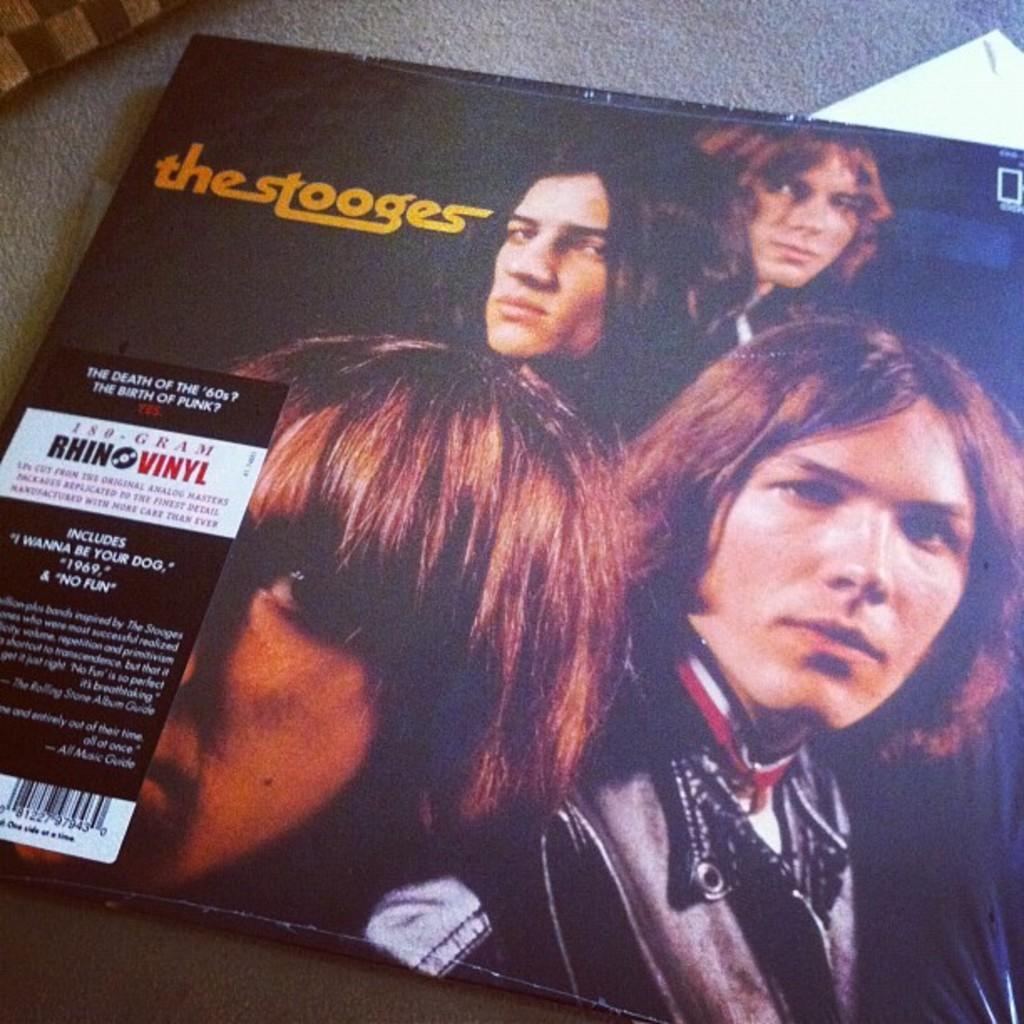How would you summarize this image in a sentence or two? In this image there is a table on that table there is a magazine, on that magazine there are four persons picture and some text is written on the magazine. 